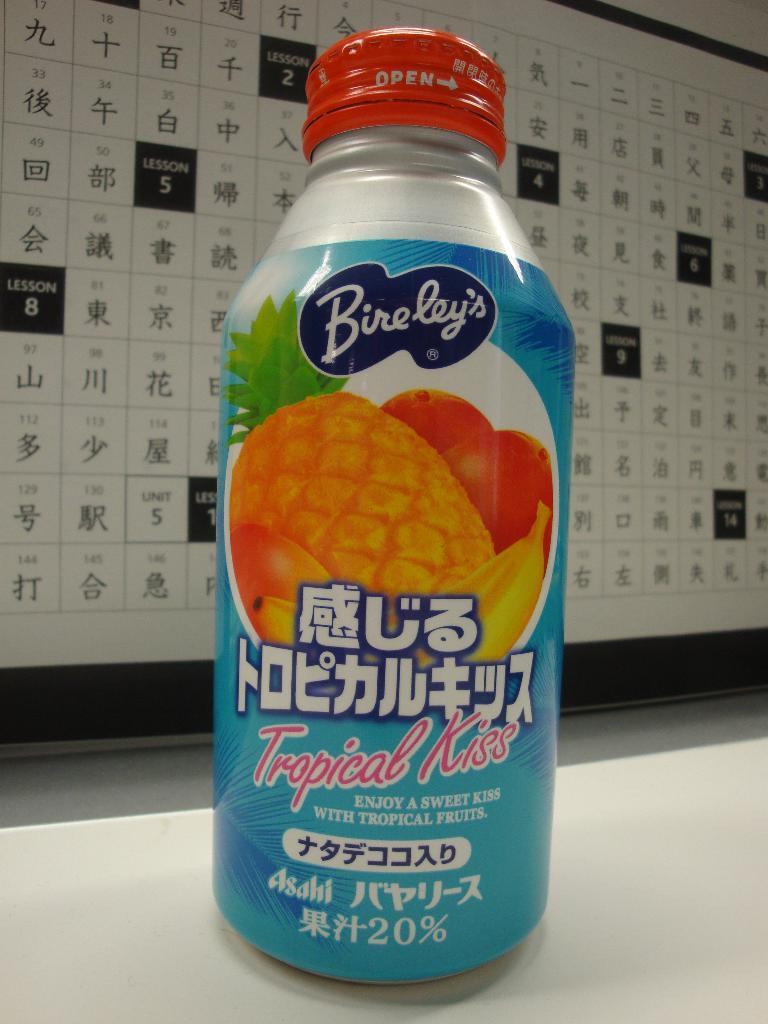<image>
Give a short and clear explanation of the subsequent image. A foreign soda has a flavor called tropical kiss. 